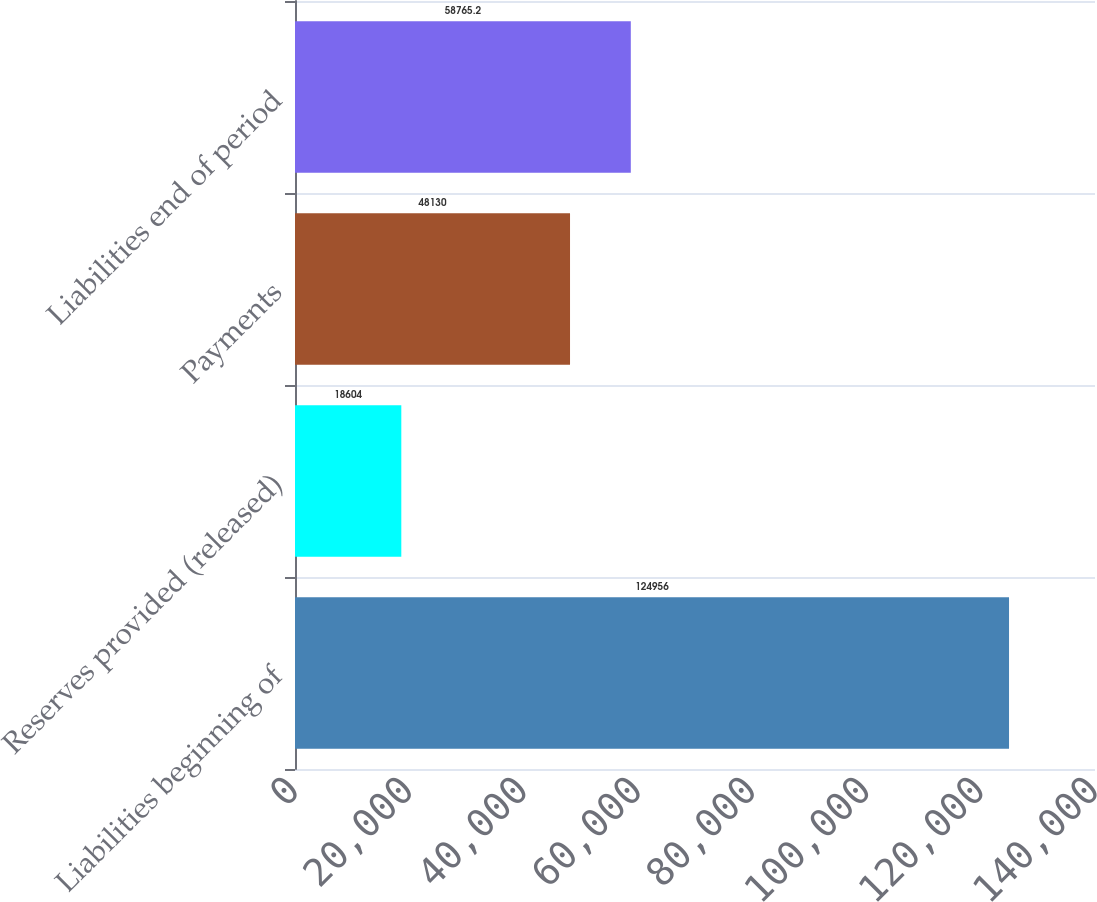Convert chart to OTSL. <chart><loc_0><loc_0><loc_500><loc_500><bar_chart><fcel>Liabilities beginning of<fcel>Reserves provided (released)<fcel>Payments<fcel>Liabilities end of period<nl><fcel>124956<fcel>18604<fcel>48130<fcel>58765.2<nl></chart> 